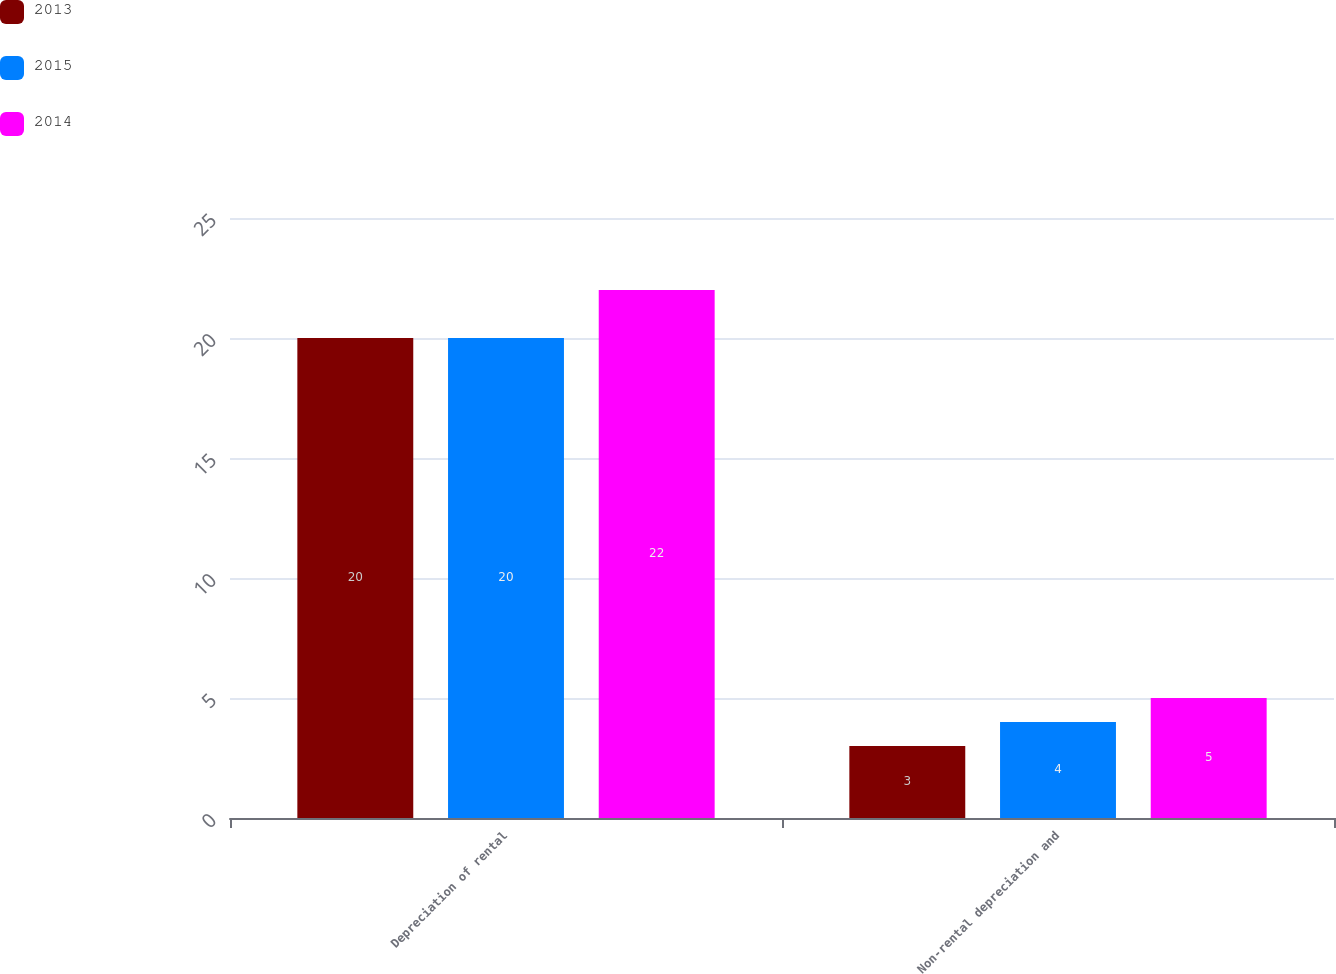<chart> <loc_0><loc_0><loc_500><loc_500><stacked_bar_chart><ecel><fcel>Depreciation of rental<fcel>Non-rental depreciation and<nl><fcel>2013<fcel>20<fcel>3<nl><fcel>2015<fcel>20<fcel>4<nl><fcel>2014<fcel>22<fcel>5<nl></chart> 